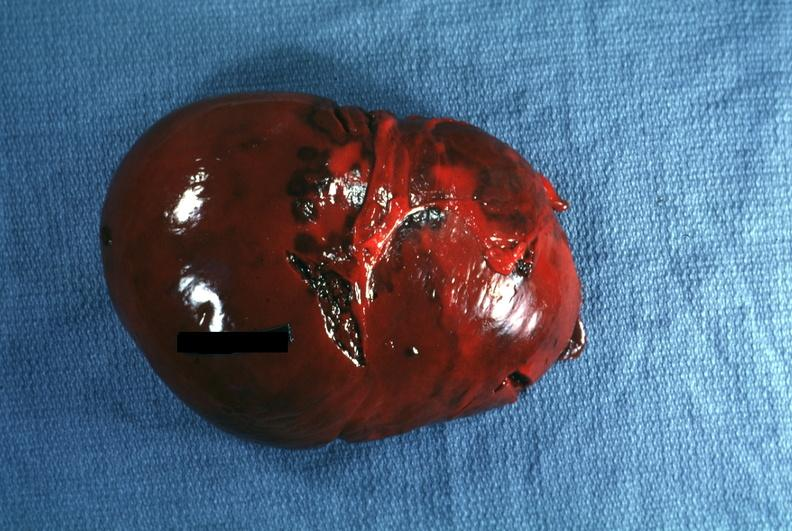does atheromatous embolus show external view several capsule lacerations easily seen?
Answer the question using a single word or phrase. No 